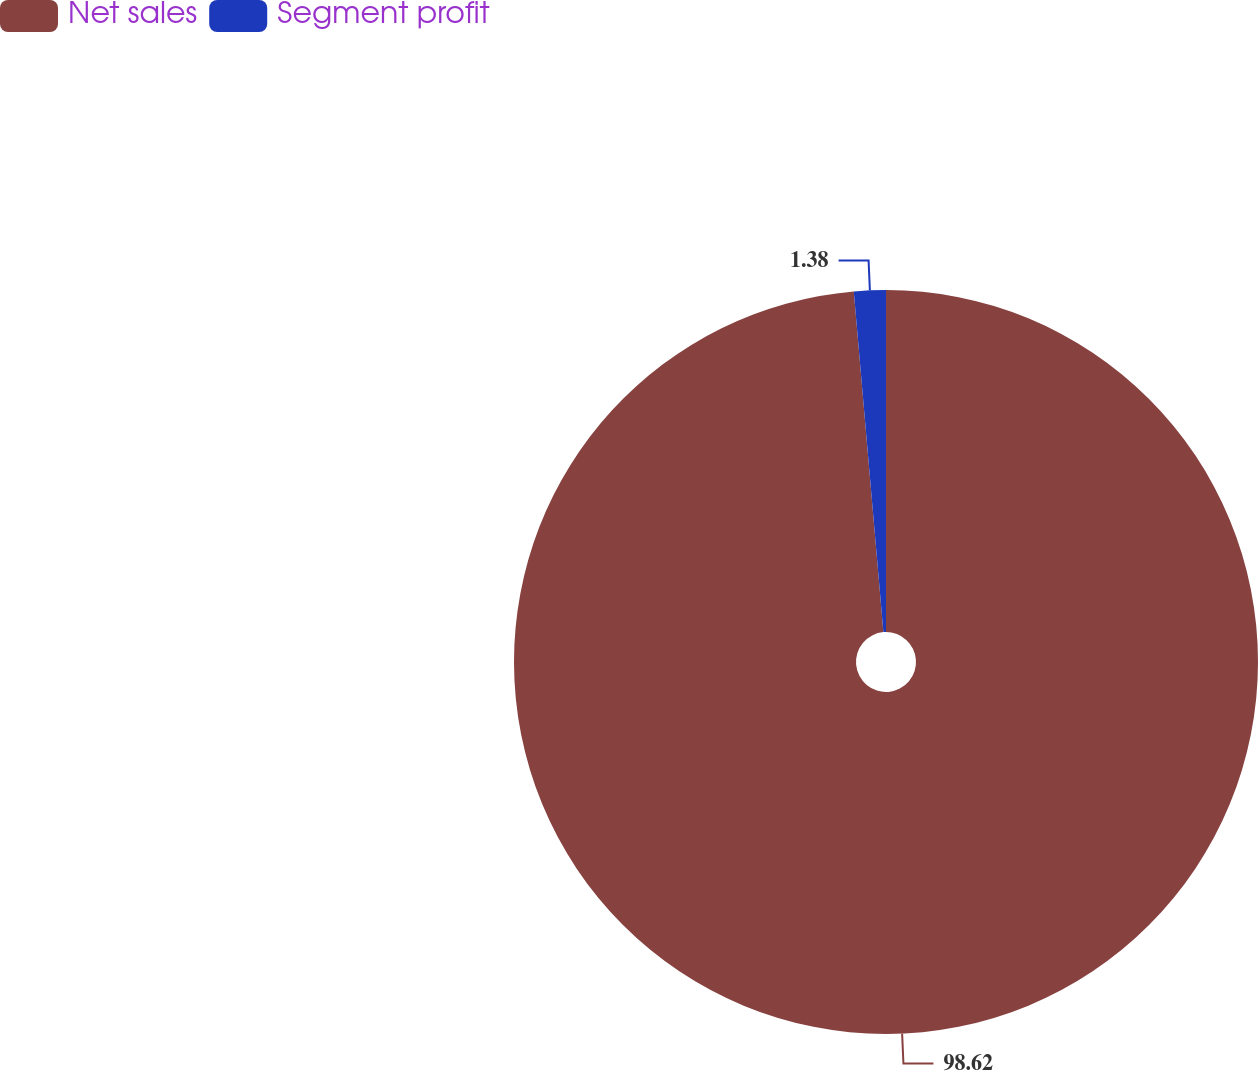Convert chart to OTSL. <chart><loc_0><loc_0><loc_500><loc_500><pie_chart><fcel>Net sales<fcel>Segment profit<nl><fcel>98.62%<fcel>1.38%<nl></chart> 